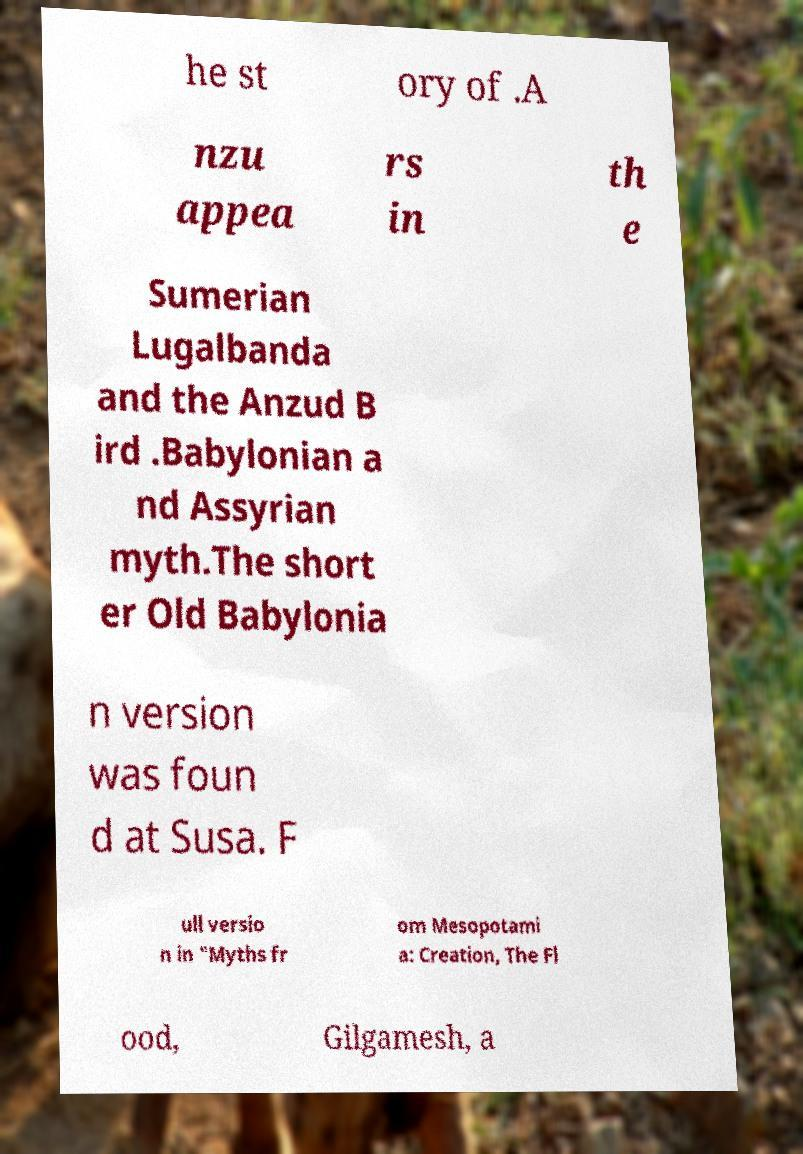Please read and relay the text visible in this image. What does it say? he st ory of .A nzu appea rs in th e Sumerian Lugalbanda and the Anzud B ird .Babylonian a nd Assyrian myth.The short er Old Babylonia n version was foun d at Susa. F ull versio n in "Myths fr om Mesopotami a: Creation, The Fl ood, Gilgamesh, a 